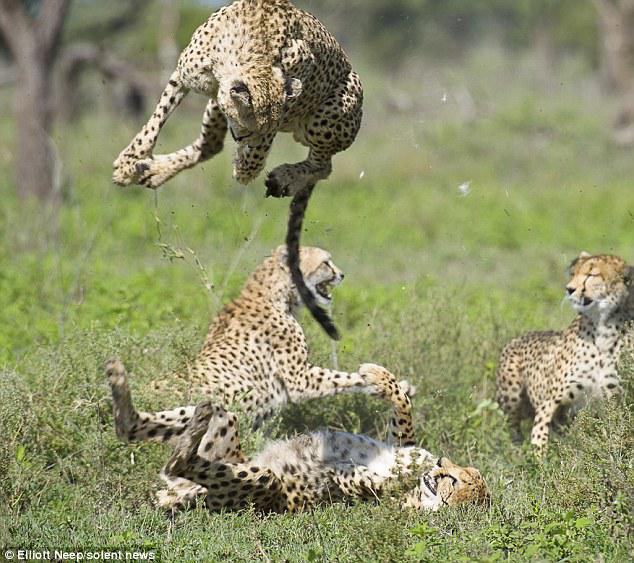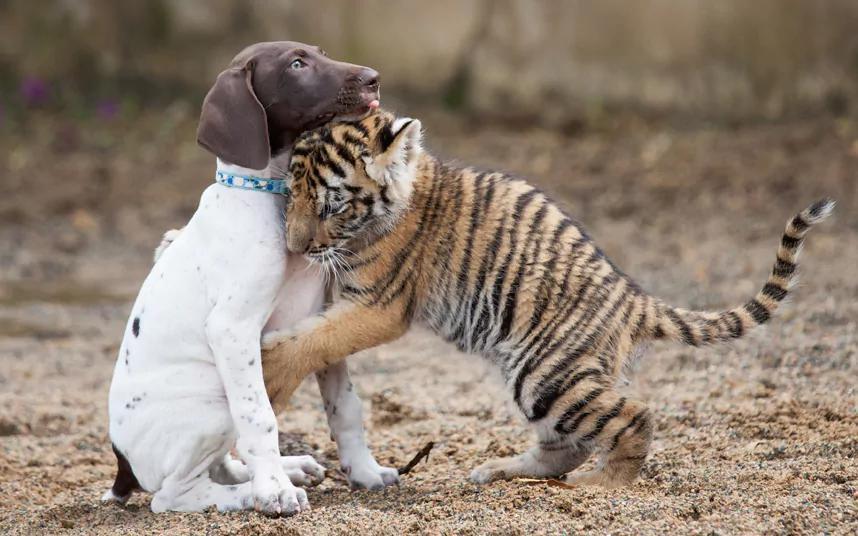The first image is the image on the left, the second image is the image on the right. Examine the images to the left and right. Is the description "At least one image shows an animal that is not a cheetah." accurate? Answer yes or no. Yes. The first image is the image on the left, the second image is the image on the right. For the images shown, is this caption "A cheetah's front paws are off the ground." true? Answer yes or no. Yes. 